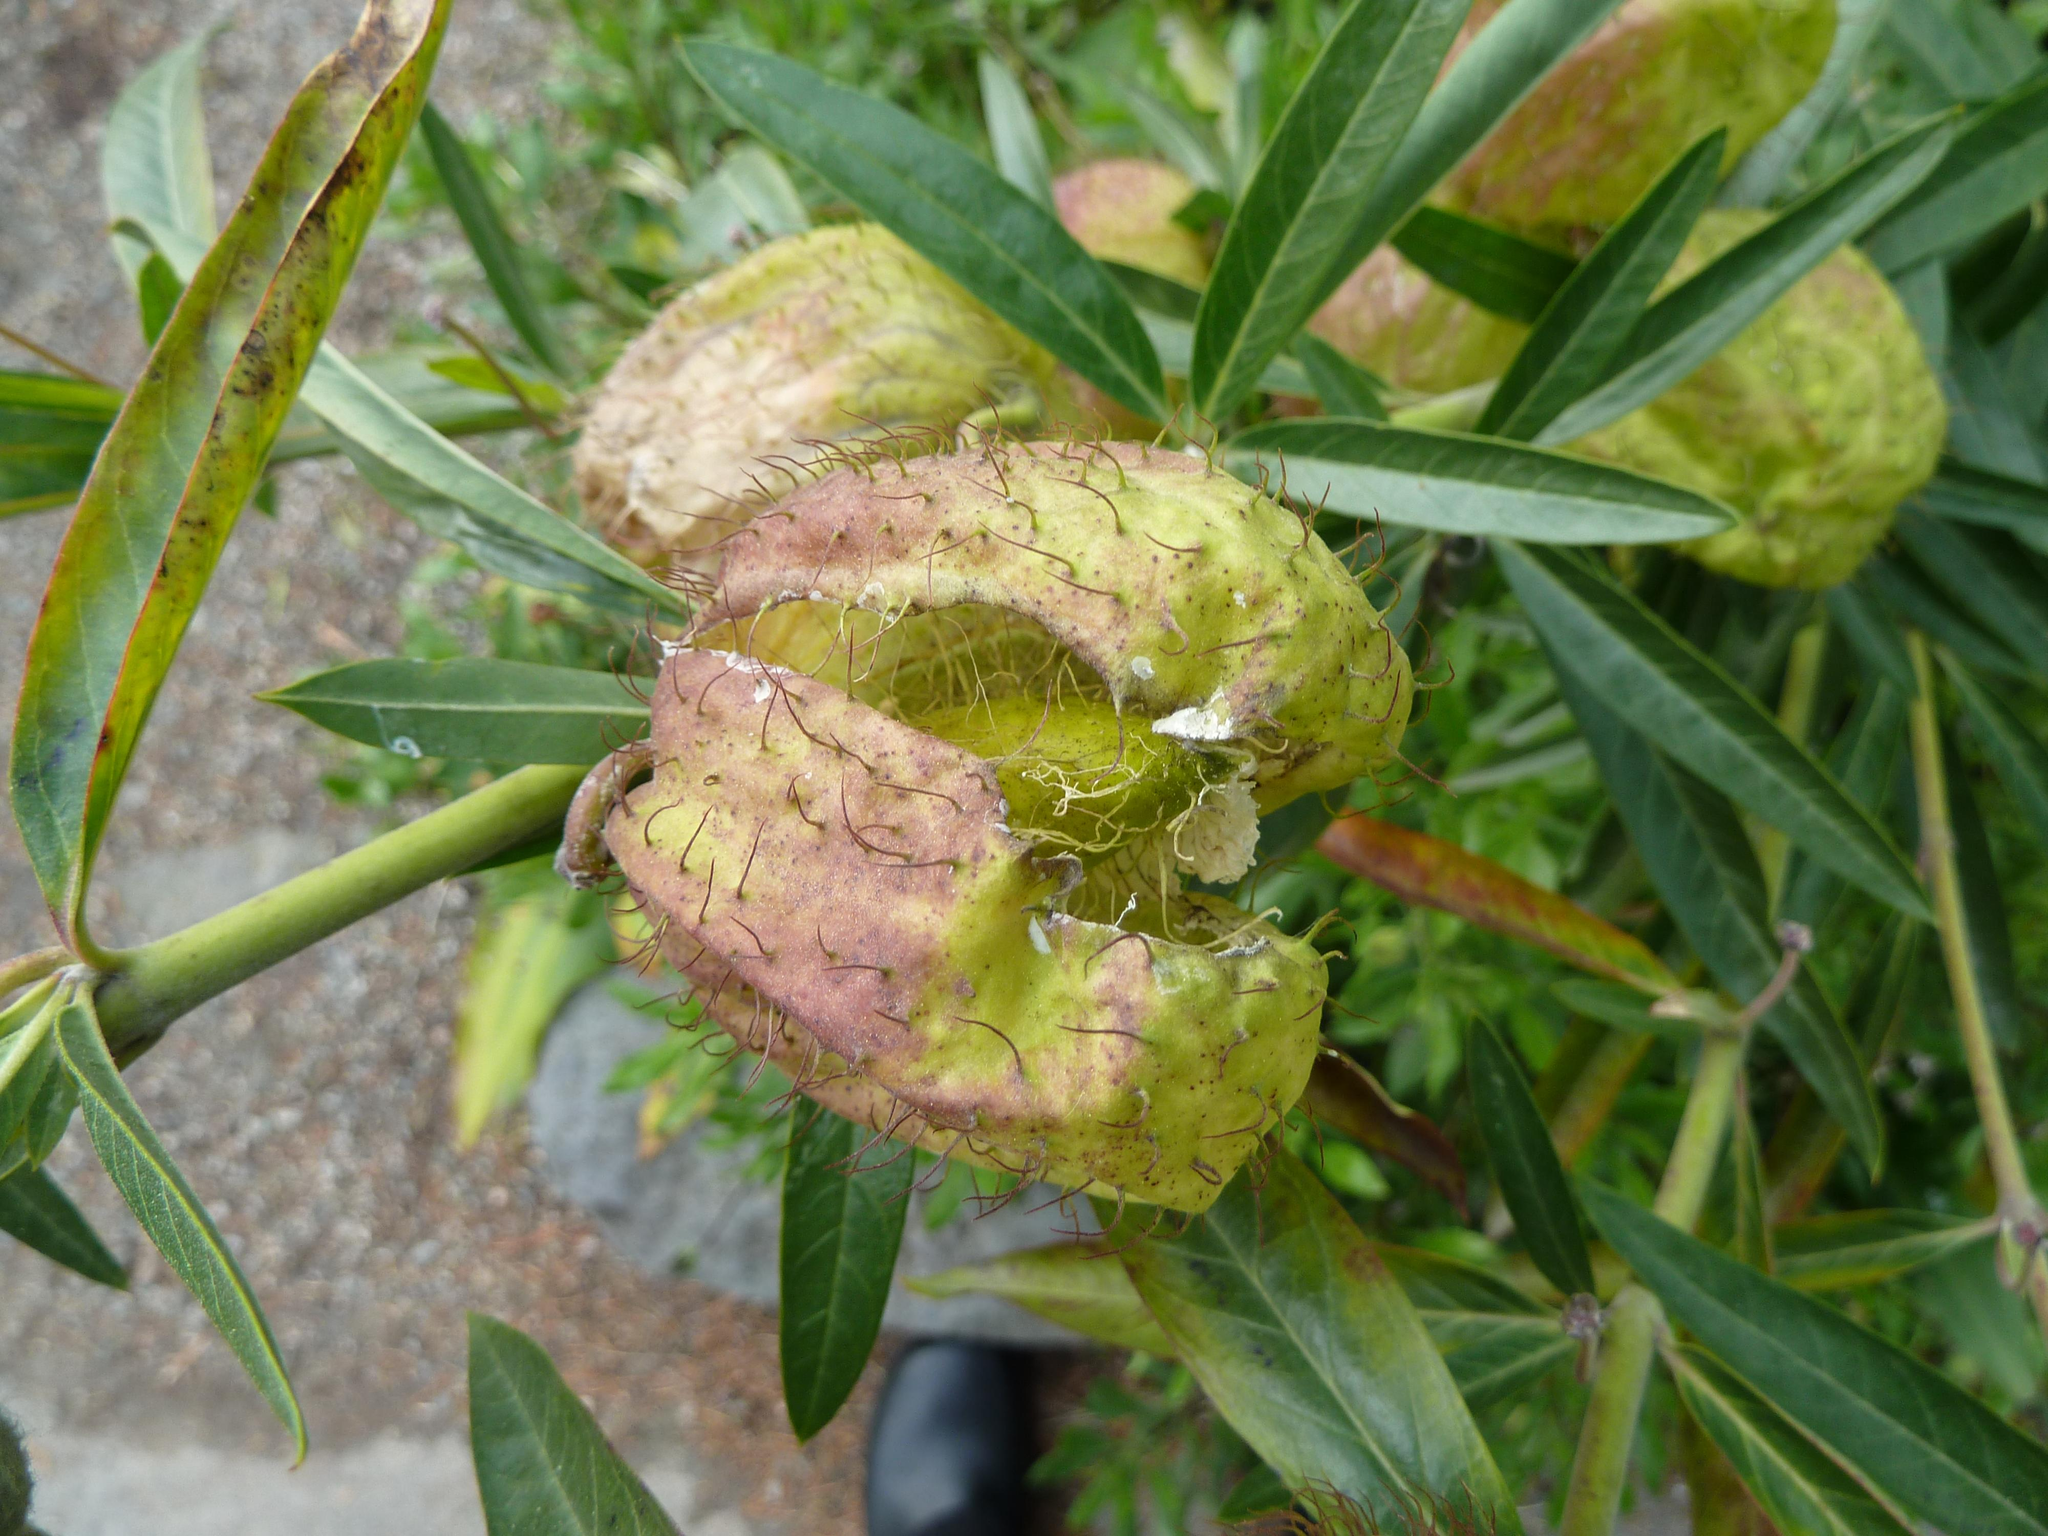What type of plant can be seen on the right side of the image? There is a plant with fruits and green leaves on the right side of the image. Are there any other plants visible in the image? Yes, there are other plants besides the mentioned plant. What is the terrain like on the left side of the image? There is dry land on the left side of the image. How many eyes can be seen on the plant in the image? Plants do not have eyes, so there are no eyes visible on the plant in the image. 